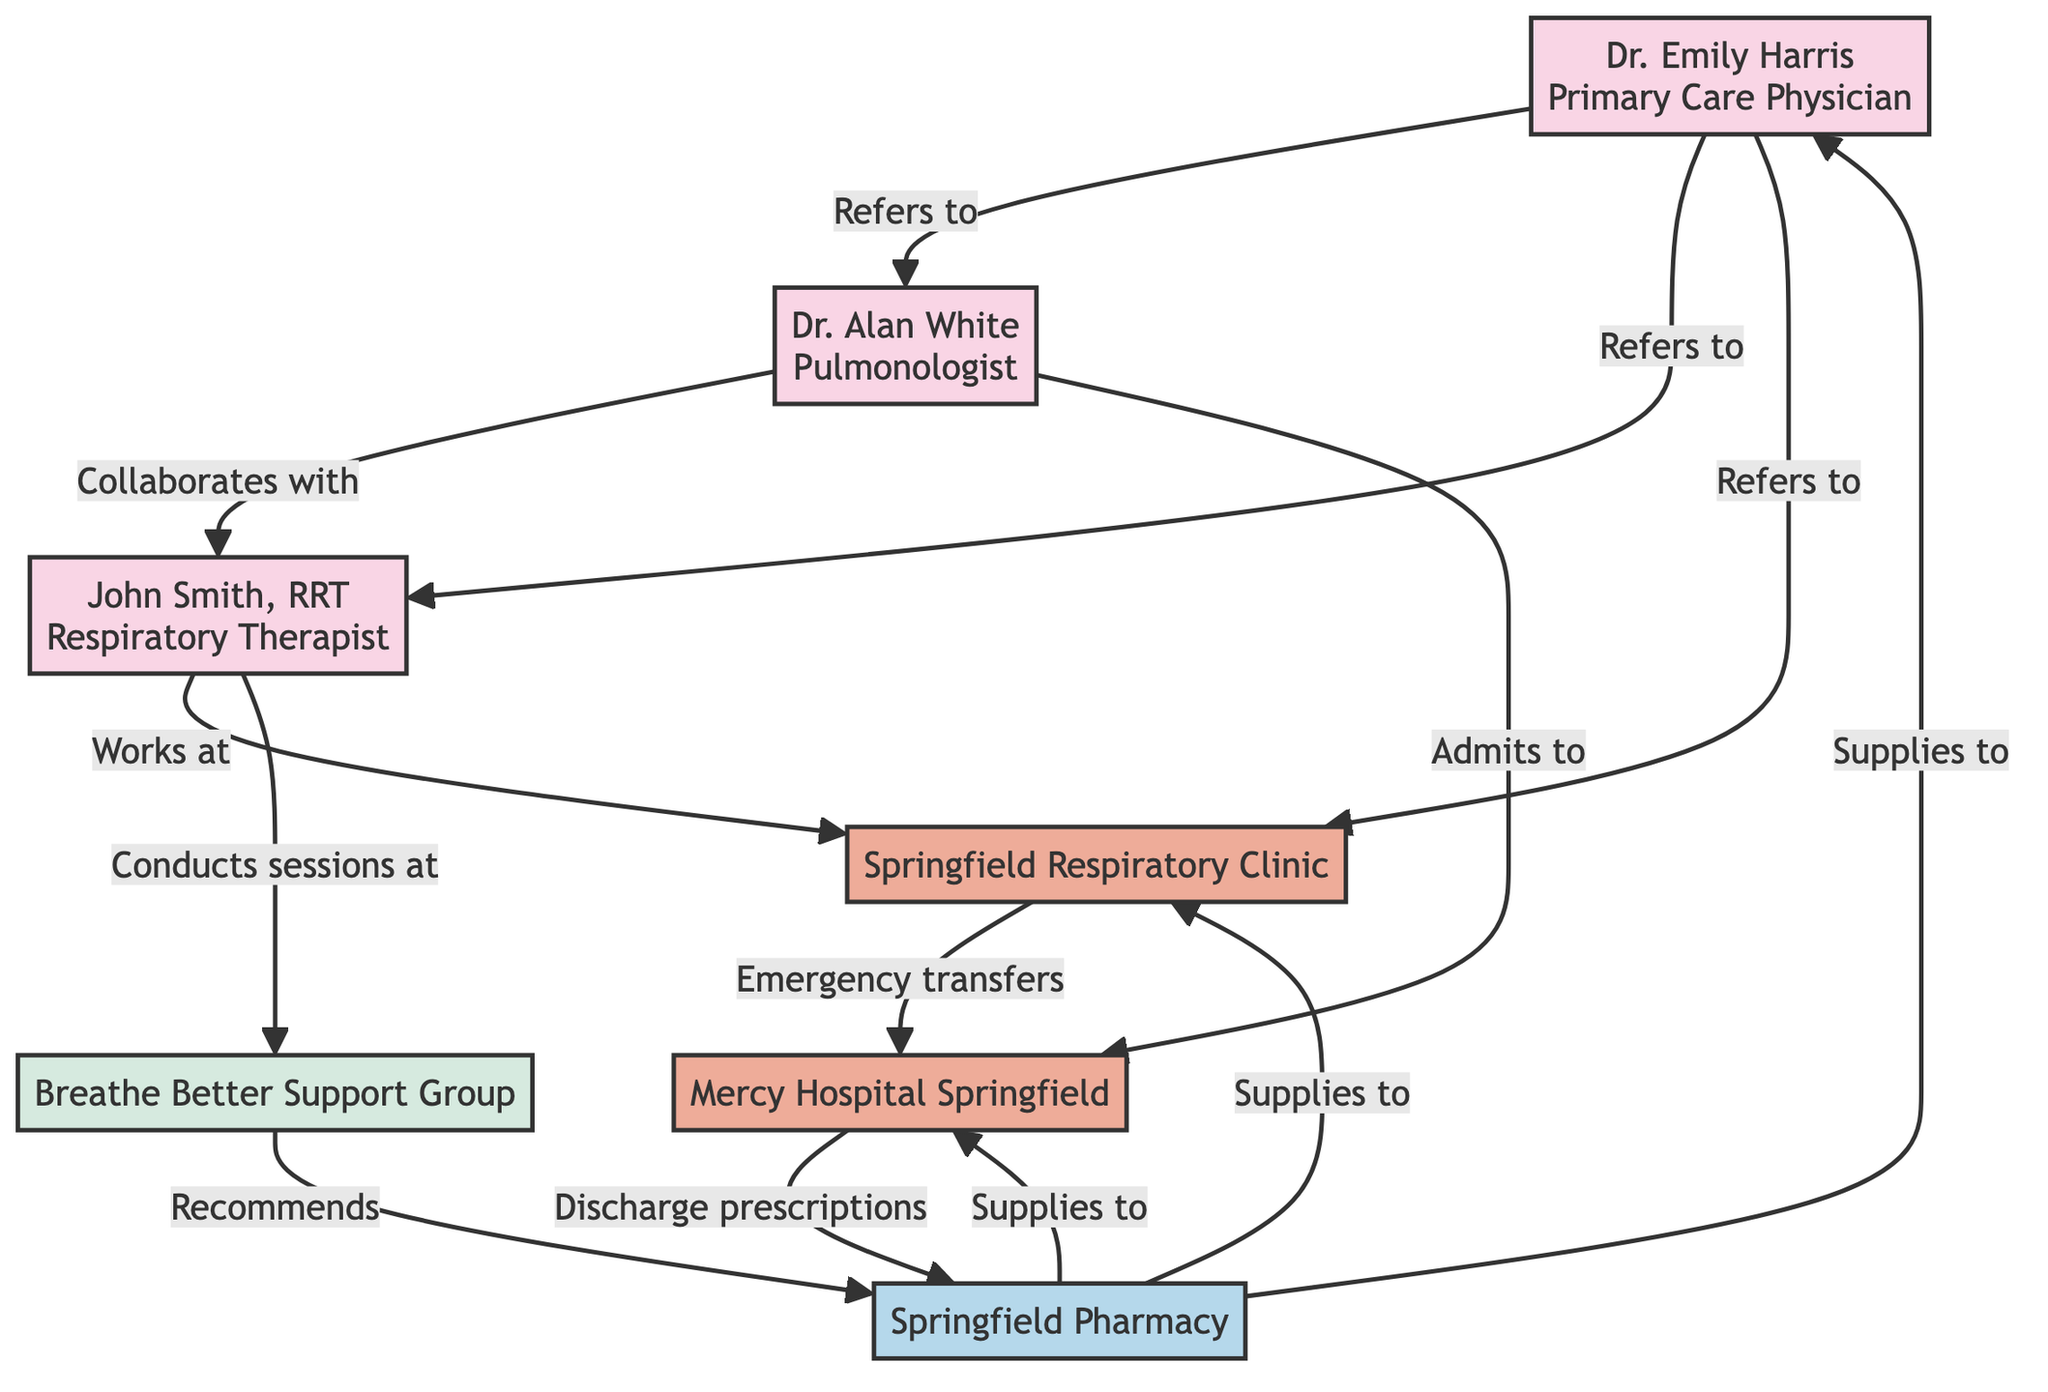What is the location of Dr. Emily Harris? The diagram shows that Dr. Emily Harris is located at Springfield Family Clinic. This is stated in the node representing her.
Answer: Springfield Family Clinic How many healthcare providers are listed in the diagram? To find this, we count the nodes labeled as providers: Dr. Emily Harris, Dr. Alan White, and John Smith, RRT. There are three providers in total.
Answer: 3 What services does the Springfield Respiratory Clinic offer? The services offered by the Springfield Respiratory Clinic include Walk-in Consultations, Spirometry Tests, and Smoking Cessation Programs. This information is detailed within the clinic's node in the diagram.
Answer: Walk-in Consultations, Spirometry Tests, Smoking Cessation Programs Which provider collaborates with John Smith, RRT? The diagram indicates that Dr. Alan White, the pulmonologist, collaborates with John Smith, RRT, as shown by the connecting line labeled "Collaborates with."
Answer: Dr. Alan White What type of relationship exists between the Pulmonologist and Mercy Hospital Springfield? The relationship noted in the diagram is that Dr. Alan White, the pulmonologist, admits to Mercy Hospital Springfield. This is indicated by the connecting line labeled "Admits to."
Answer: Admits to What kind of support does the Breathe Better Support Group provide? The diagram lists the Breathe Better Support Group as providing Weekly Meetings, Peer Support, and Guest Speaker Sessions. This can be seen within the group's node.
Answer: Weekly Meetings, Peer Support, Guest Speaker Sessions How does the Springfield Pharmacy interact with other nodes? The Springfield Pharmacy interacts with several nodes: it supplies to primary care physicians, the Springfield Respiratory Clinic, and Mercy Hospital Springfield. These connections are clearly marked in the diagram.
Answer: Supplies to PCP, Clinic, HOSP What is the service provided by John Smith, RRT? The services provided by John Smith, RRT, include Breathing Exercises, Pulmonary Rehabilitation, and Oxygen Therapy Management. These details are found within his node on the diagram.
Answer: Breathing Exercises, Pulmonary Rehabilitation, Oxygen Therapy Management How does the Springfield Respiratory Clinic transfer emergencies? The diagram indicates that the Springfield Respiratory Clinic has a connection labeled "Emergency transfers" to Mercy Hospital Springfield, meaning it can refer emergency cases to the hospital.
Answer: Emergency transfers 